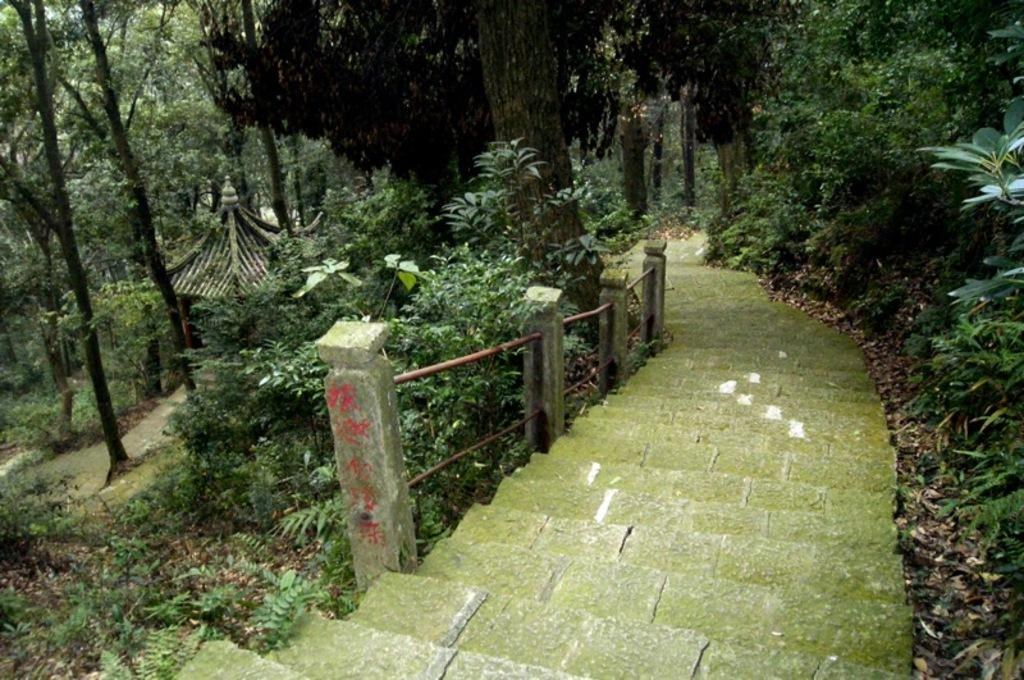What can be seen in the image that people might use to move between different levels? There are steps in the image that people might use to move between different levels. What type of natural environment is visible in the image? There are many trees around the steps in the image, indicating a natural environment. What type of crime is being committed in the image? There is no indication of any crime being committed in the image; it primarily features steps and trees. What is the weight of the leaf on the tree in the image? There is no specific leaf mentioned in the image, and even if there were, it would be difficult to determine its weight without additional information. 